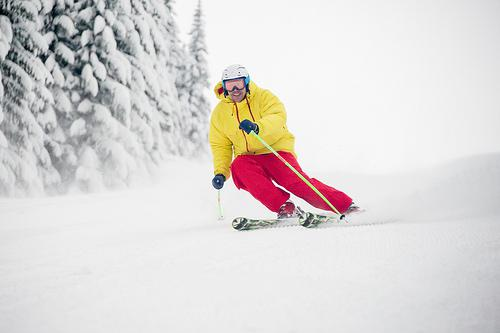Question: when was this taken?
Choices:
A. Daytime.
B. Summer.
C. Midnight.
D. Winter.
Answer with the letter. Answer: D Question: what color are the person's pants?
Choices:
A. White.
B. Red.
C. Blue.
D. Black.
Answer with the letter. Answer: B Question: what is on the person's feet?
Choices:
A. Shoes.
B. Skis.
C. Socks.
D. Cleats.
Answer with the letter. Answer: B Question: where was this taken?
Choices:
A. Tennis Court.
B. Hot Tub.
C. Ski slope.
D. Parking Lot.
Answer with the letter. Answer: C 